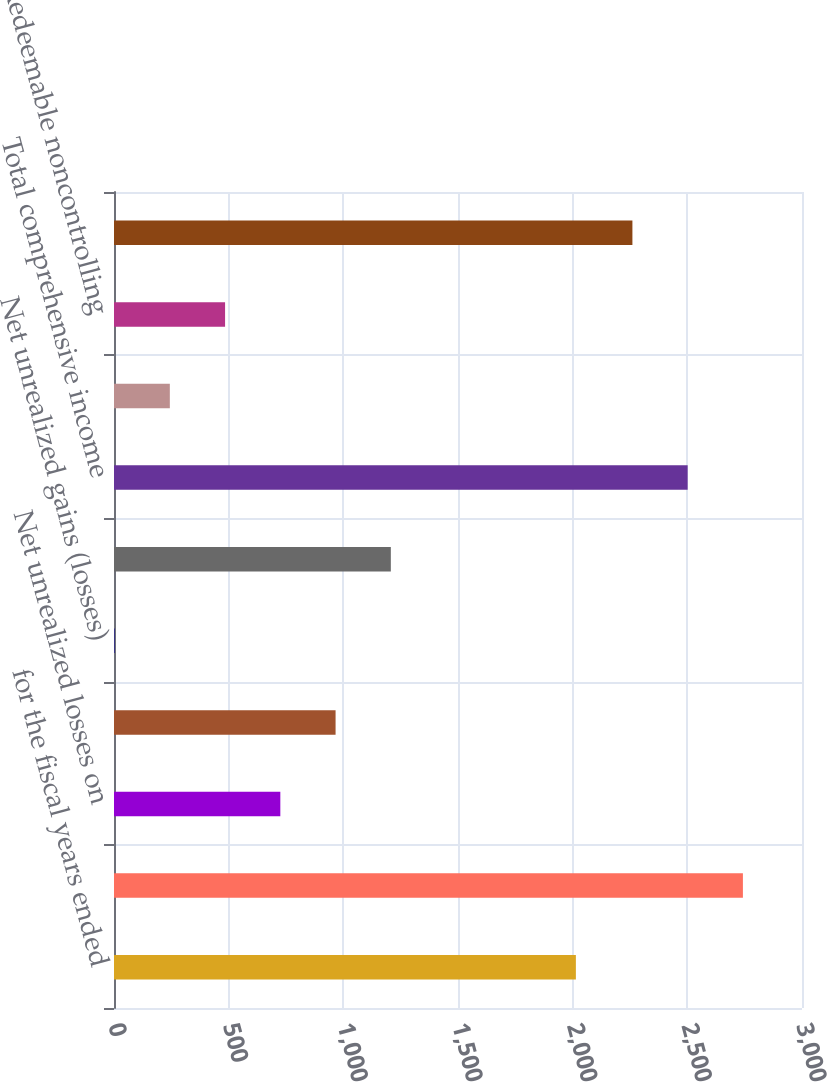<chart> <loc_0><loc_0><loc_500><loc_500><bar_chart><fcel>for the fiscal years ended<fcel>Net Income<fcel>Net unrealized losses on<fcel>Currency translation<fcel>Net unrealized gains (losses)<fcel>Total other comprehensive loss<fcel>Total comprehensive income<fcel>Nonredeemable noncontrolling<fcel>Redeemable noncontrolling<fcel>Comprehensive Income<nl><fcel>2014<fcel>2742.34<fcel>725.26<fcel>966.18<fcel>2.5<fcel>1207.1<fcel>2501.42<fcel>243.42<fcel>484.34<fcel>2260.5<nl></chart> 